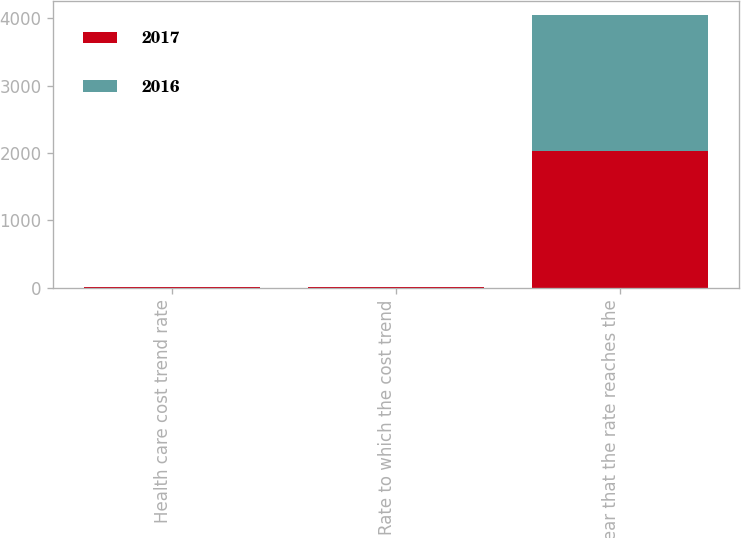Convert chart. <chart><loc_0><loc_0><loc_500><loc_500><stacked_bar_chart><ecel><fcel>Health care cost trend rate<fcel>Rate to which the cost trend<fcel>Year that the rate reaches the<nl><fcel>2017<fcel>7.3<fcel>5<fcel>2026<nl><fcel>2016<fcel>7.28<fcel>5<fcel>2026<nl></chart> 